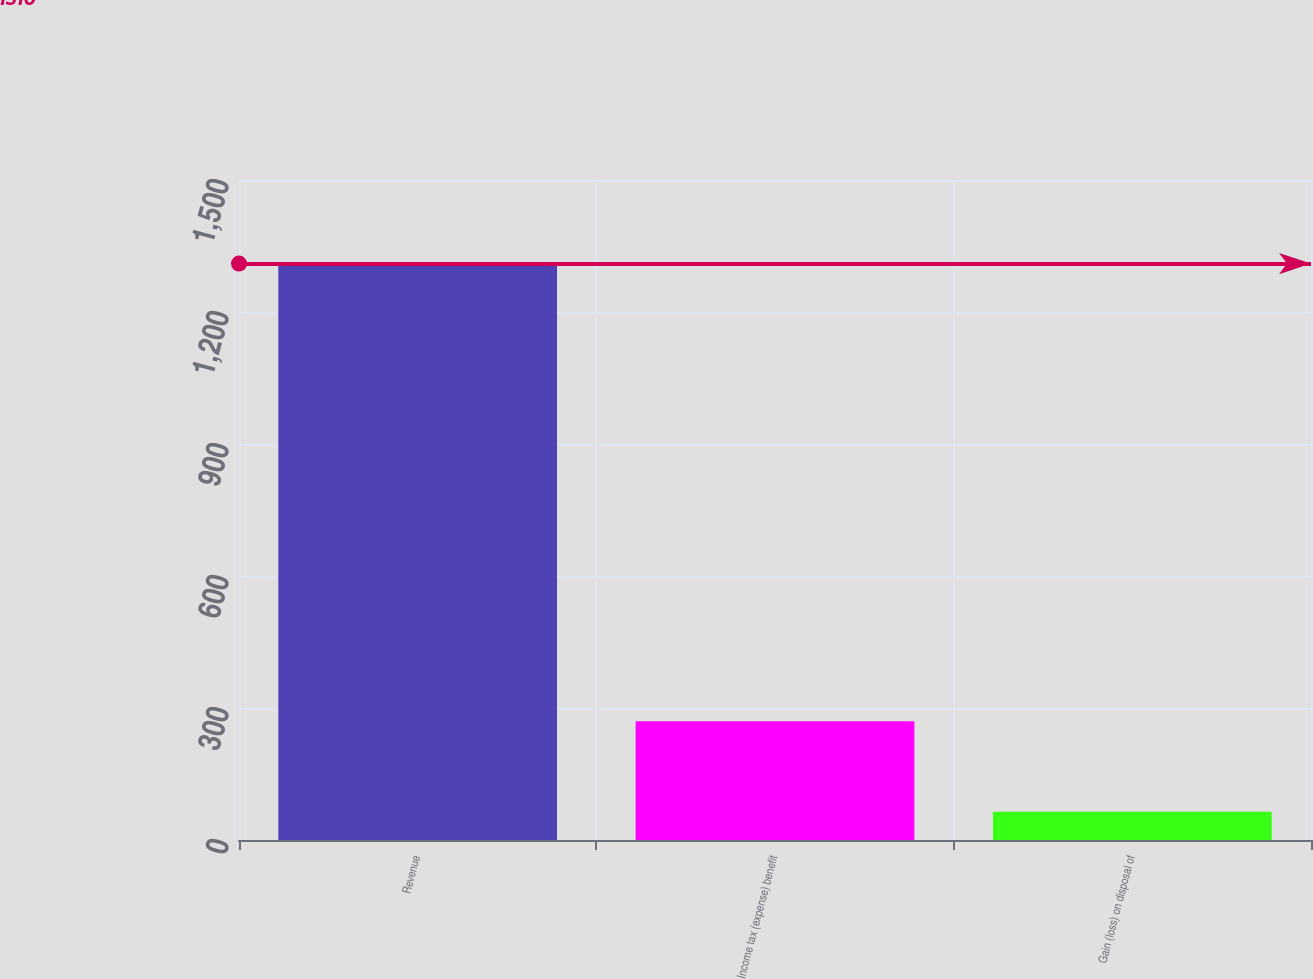Convert chart. <chart><loc_0><loc_0><loc_500><loc_500><bar_chart><fcel>Revenue<fcel>Income tax (expense) benefit<fcel>Gain (loss) on disposal of<nl><fcel>1310<fcel>270<fcel>64<nl></chart> 